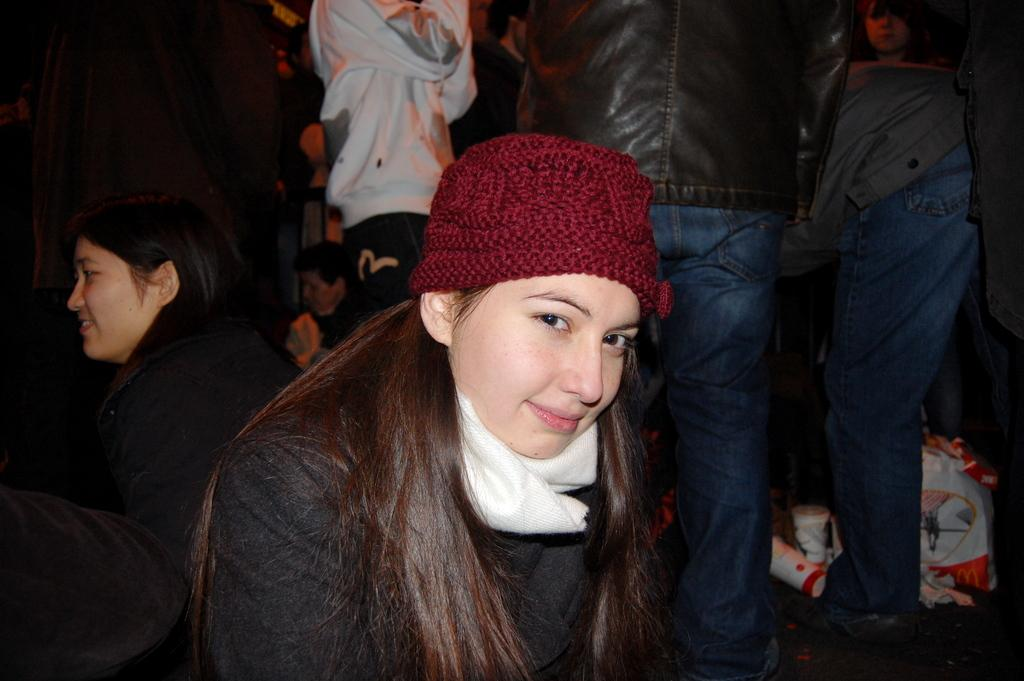Who is the main subject in the image? There is a lady in the center of the image. What is the lady wearing on her head? The lady is wearing a red color cap. What color is the dress worn by the lady? The lady is wearing a black color dress. Can you describe the background of the image? There are many persons in the background of the image. What type of punishment is being administered to the lady in the image? There is no indication of punishment in the image; the lady is simply standing in the center wearing a red cap and black dress. 